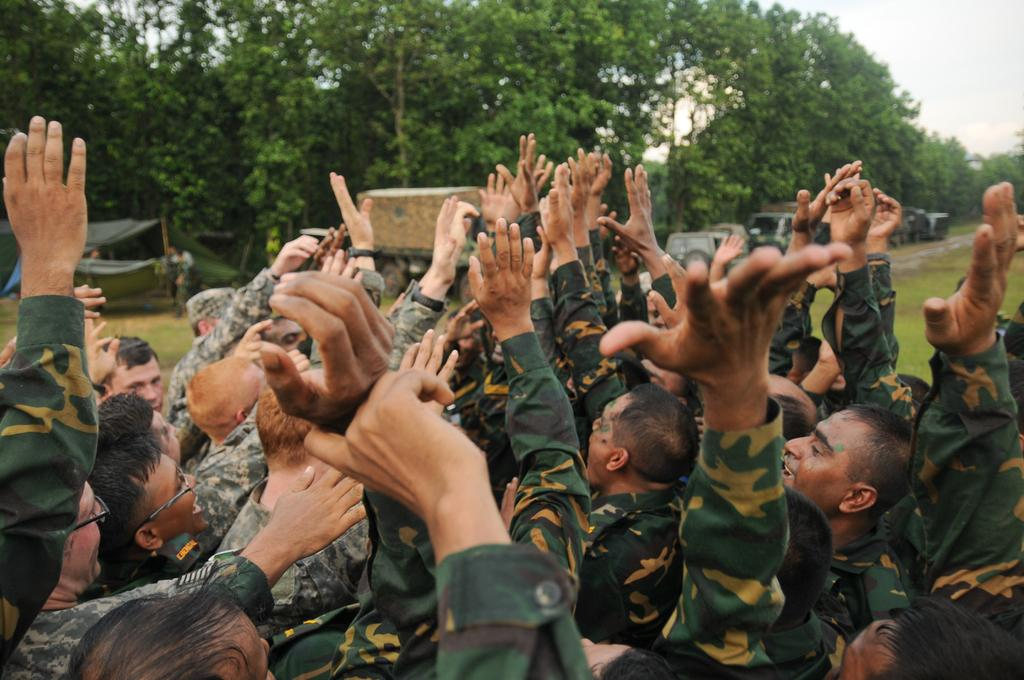What are the people in the image doing with their hands? The persons standing in the image have raised their hands up. What can be seen in the background of the image? There is a tent, vehicles, trees, and clouds in the sky in the background of the image. How are the persons sorting the water in the image? There is no water present in the image, and the persons are not sorting anything. 